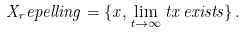<formula> <loc_0><loc_0><loc_500><loc_500>X _ { r } e p e l l i n g = \{ x , \lim _ { t \to \infty } t x \, e x i s t s \} \, .</formula> 